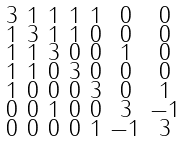<formula> <loc_0><loc_0><loc_500><loc_500>\begin{smallmatrix} 3 & 1 & 1 & 1 & 1 & 0 & 0 \\ 1 & 3 & 1 & 1 & 0 & 0 & 0 \\ 1 & 1 & 3 & 0 & 0 & 1 & 0 \\ 1 & 1 & 0 & 3 & 0 & 0 & 0 \\ 1 & 0 & 0 & 0 & 3 & 0 & 1 \\ 0 & 0 & 1 & 0 & 0 & 3 & - 1 \\ 0 & 0 & 0 & 0 & 1 & - 1 & 3 \end{smallmatrix}</formula> 